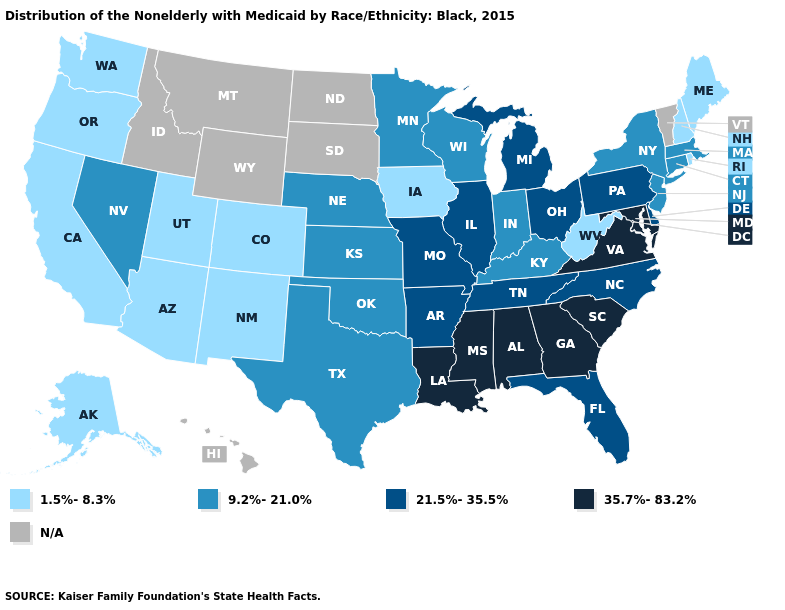Name the states that have a value in the range 9.2%-21.0%?
Answer briefly. Connecticut, Indiana, Kansas, Kentucky, Massachusetts, Minnesota, Nebraska, Nevada, New Jersey, New York, Oklahoma, Texas, Wisconsin. Does Virginia have the highest value in the USA?
Keep it brief. Yes. Which states have the lowest value in the MidWest?
Keep it brief. Iowa. Name the states that have a value in the range 1.5%-8.3%?
Give a very brief answer. Alaska, Arizona, California, Colorado, Iowa, Maine, New Hampshire, New Mexico, Oregon, Rhode Island, Utah, Washington, West Virginia. What is the value of Hawaii?
Concise answer only. N/A. Name the states that have a value in the range N/A?
Quick response, please. Hawaii, Idaho, Montana, North Dakota, South Dakota, Vermont, Wyoming. Among the states that border Arkansas , which have the lowest value?
Concise answer only. Oklahoma, Texas. What is the value of Alaska?
Keep it brief. 1.5%-8.3%. Among the states that border Nevada , which have the highest value?
Short answer required. Arizona, California, Oregon, Utah. What is the value of Michigan?
Concise answer only. 21.5%-35.5%. Among the states that border Missouri , which have the lowest value?
Write a very short answer. Iowa. Does the map have missing data?
Answer briefly. Yes. Does Arizona have the lowest value in the USA?
Keep it brief. Yes. What is the value of Vermont?
Give a very brief answer. N/A. 